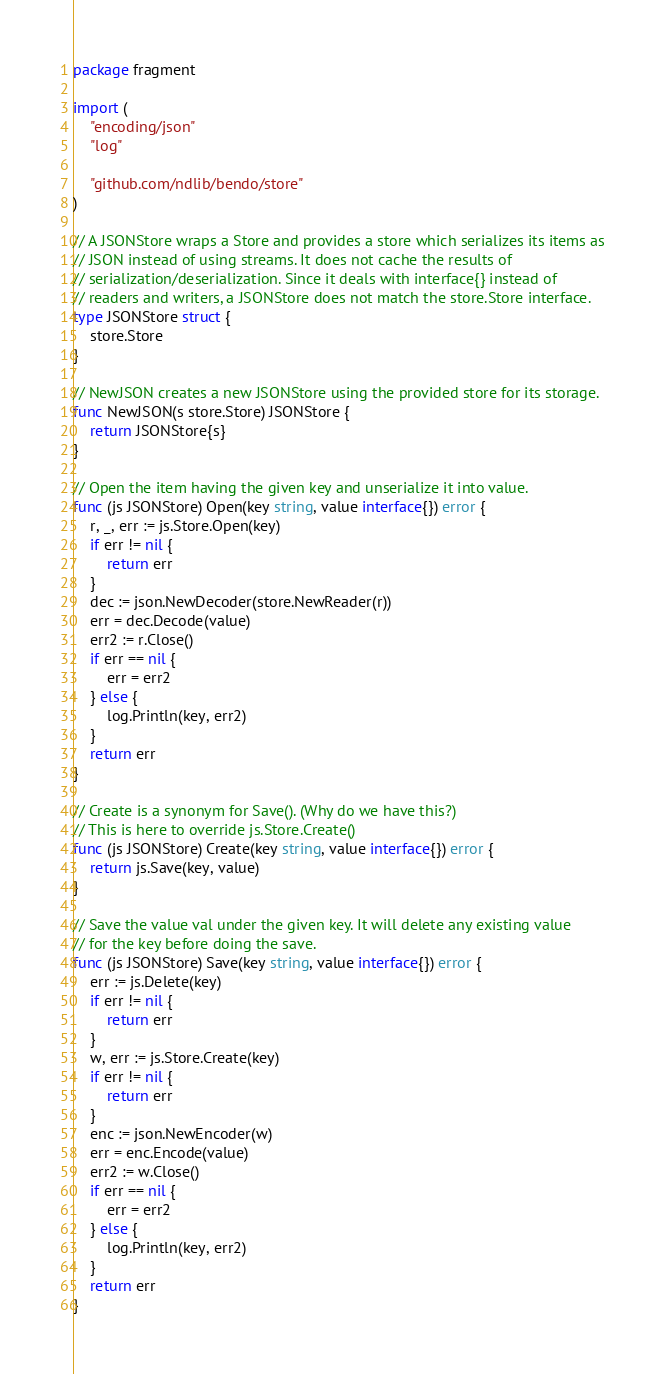Convert code to text. <code><loc_0><loc_0><loc_500><loc_500><_Go_>package fragment

import (
	"encoding/json"
	"log"

	"github.com/ndlib/bendo/store"
)

// A JSONStore wraps a Store and provides a store which serializes its items as
// JSON instead of using streams. It does not cache the results of
// serialization/deserialization. Since it deals with interface{} instead of
// readers and writers, a JSONStore does not match the store.Store interface.
type JSONStore struct {
	store.Store
}

// NewJSON creates a new JSONStore using the provided store for its storage.
func NewJSON(s store.Store) JSONStore {
	return JSONStore{s}
}

// Open the item having the given key and unserialize it into value.
func (js JSONStore) Open(key string, value interface{}) error {
	r, _, err := js.Store.Open(key)
	if err != nil {
		return err
	}
	dec := json.NewDecoder(store.NewReader(r))
	err = dec.Decode(value)
	err2 := r.Close()
	if err == nil {
		err = err2
	} else {
		log.Println(key, err2)
	}
	return err
}

// Create is a synonym for Save(). (Why do we have this?)
// This is here to override js.Store.Create()
func (js JSONStore) Create(key string, value interface{}) error {
	return js.Save(key, value)
}

// Save the value val under the given key. It will delete any existing value
// for the key before doing the save.
func (js JSONStore) Save(key string, value interface{}) error {
	err := js.Delete(key)
	if err != nil {
		return err
	}
	w, err := js.Store.Create(key)
	if err != nil {
		return err
	}
	enc := json.NewEncoder(w)
	err = enc.Encode(value)
	err2 := w.Close()
	if err == nil {
		err = err2
	} else {
		log.Println(key, err2)
	}
	return err
}
</code> 